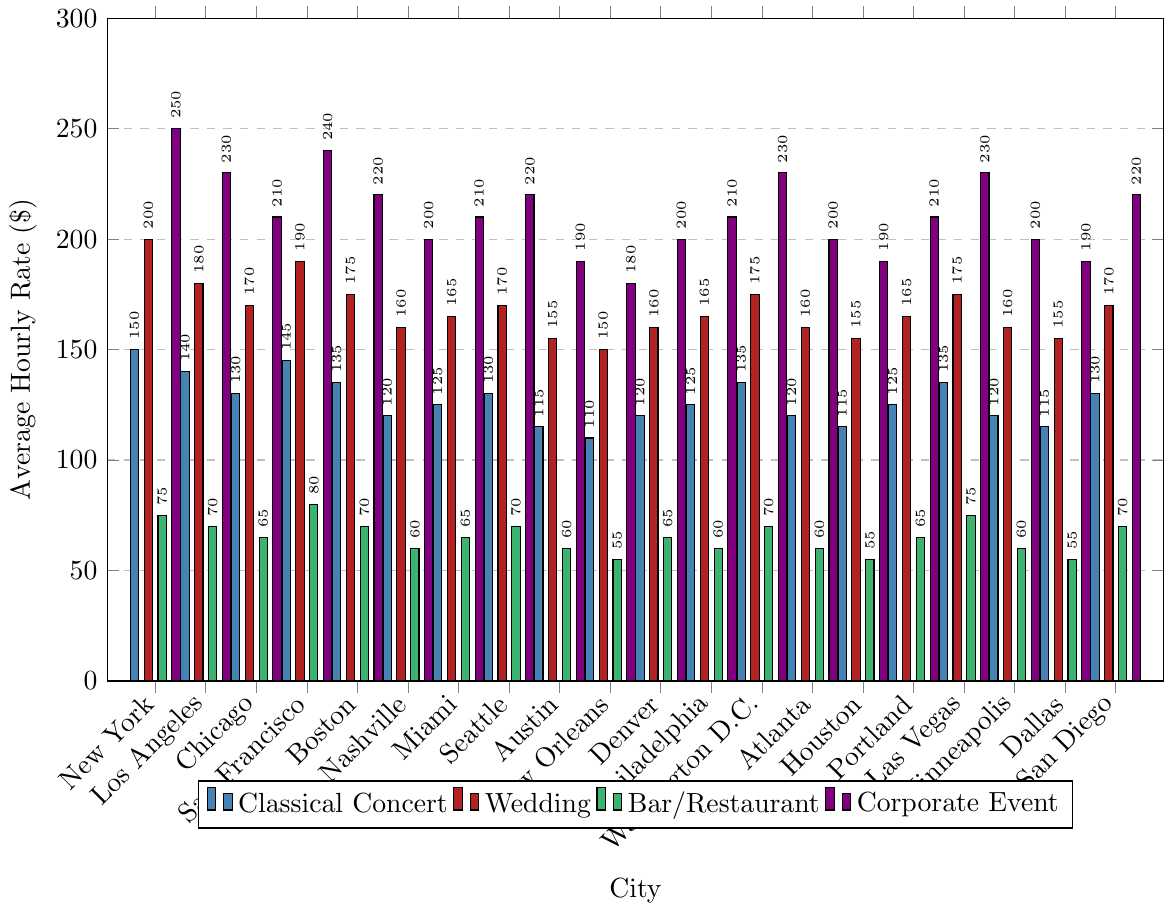Which city has the highest average hourly rate for Classical Concert gigs? Look for the tallest blue bar in the chart, which corresponds to New York
Answer: New York Compare the hourly rates for Wedding gigs in Boston and Los Angeles. Which city offers a higher rate? Compare the heights of the red bars for Boston and Los Angeles. The bar for Boston is higher
Answer: Boston What is the sum of hourly rates for Bar/Restaurant gigs in New York and Las Vegas? Add the hourly rates for Bar/Restaurant gigs in New York ($75) and Las Vegas ($75): 75 + 75 = 150
Answer: 150 What is the difference between the average hourly rate for Corporate Events in Chicago and Miami? Subtract the hourly rate for Miami ($210) from Chicago ($240): 240 - 210 = 30
Answer: 30 Which type of musical gig generally has the lowest hourly rate across the cities? Identify the color with the lowest bars overall. Green bars for Bar/Restaurant gigs are generally the shortest
Answer: Bar/Restaurant What’s the average hourly rate for Classical Concert gigs in the top five cities by alphabetical order? The top five cities are: Atlanta, Austin, Boston, Chicago, Dallas. Calculate the average: (120 + 115 + 135 + 130 + 115) / 5 = 123
Answer: 123 In which city do musicians earn the least for Wedding gigs? Identify the shortest red bar in the chart, which corresponds to New Orleans
Answer: New Orleans How does the hourly rate for Corporate Events in Portland compare to that in Denver? Compare the purple bars for Portland and Denver. Both bars are at the same height
Answer: Equal What mathematical operations are needed to determine the average rate for Corporate Events in the presented cities? Sum all the hourly rates for Corporate Events and divide by the number of cities (20). The rates are: 250, 230, 210, 240, 220, 200, 210, 220, 190, 180, 200, 210, 230, 200, 190, 210, 230, 200, 190, 220. Sum = 4150, average = 4150 / 20 = 207.5
Answer: Sum and division: 207.5 